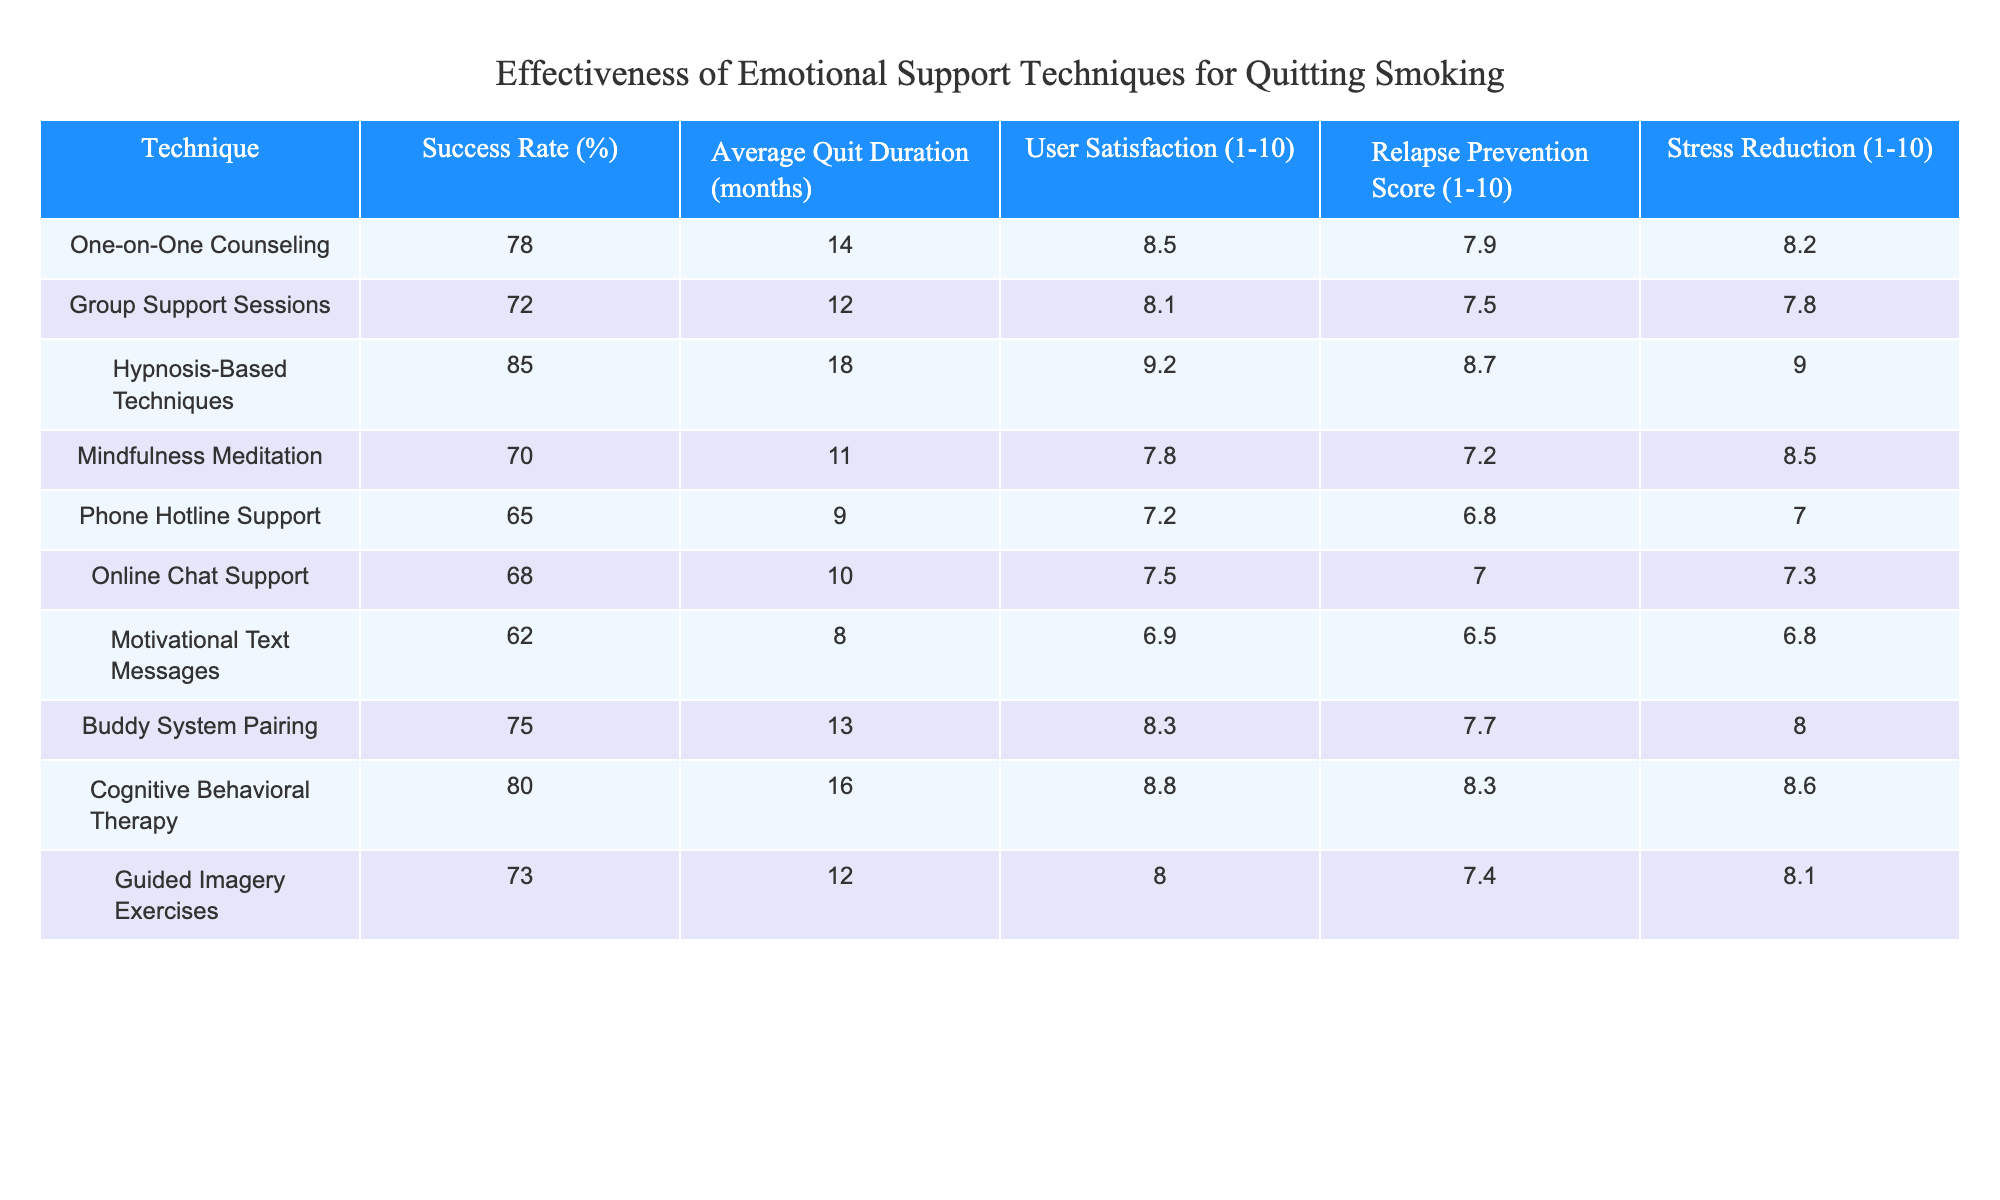What is the success rate of hypnosis-based techniques? The success rate of hypnosis-based techniques is provided in the table under the "Success Rate (%)" column, which shows a value of 85%.
Answer: 85% Which emotional support technique has the highest user satisfaction? Looking at the "User Satisfaction (1-10)" column, hypnosis-based techniques have the highest satisfaction score of 9.2.
Answer: Hypnosis-Based Techniques What is the average quit duration for individuals using cognitive behavioral therapy? The average quit duration for cognitive behavioral therapy is listed in the "Average Quit Duration (months)" column, showing a value of 16 months.
Answer: 16 months Is the success rate of the buddy system pairing greater than that of the online chat support? The success rate for the buddy system pairing is 75%, while for online chat support, it is 68%. Since 75% is greater than 68%, the answer is yes.
Answer: Yes What is the difference in average quit duration between hypnosis-based techniques and mindfulness meditation? Hypnosis-based techniques have an average quit duration of 18 months, while mindfulness meditation has an average of 11 months. The difference is 18 - 11 = 7 months.
Answer: 7 months How many techniques have a success rate above 75%? Looking through the "Success Rate (%)" column, we can count four techniques: hypnosis-based techniques (85%), cognitive behavioral therapy (80%), one-on-one counseling (78%), and buddy system pairing (75%). Thus, there are four techniques above 75%.
Answer: 4 techniques What is the average user satisfaction score for techniques with a success rate below 70%? The following techniques have success rates below 70%: phone hotline support (65%), online chat support (68%), and motivational text messages (62%). Their user satisfaction scores are 7.2, 7.5, and 6.9, respectively. The average is (7.2 + 7.5 + 6.9) / 3 = 7.2.
Answer: 7.2 Does guided imagery exercises have a higher stress reduction score than group support sessions? Guided imagery exercises have a stress reduction score of 8.1, while group support sessions have a score of 7.8. Since 8.1 is greater than 7.8, the answer is yes.
Answer: Yes What is the combined score for relapse prevention and stress reduction for the technique with the lowest success rate? The technique with the lowest success rate is motivational text messages at 62%. Its relapse prevention score is 6.5 and stress reduction score is 6.8. The combined score is 6.5 + 6.8 = 13.3.
Answer: 13.3 Which technique would you recommend based on both high success and high user satisfaction? Hypnosis-based techniques have the highest success rate (85%) and user satisfaction (9.2), making them the most recommended based on these criteria.
Answer: Hypnosis-Based Techniques 